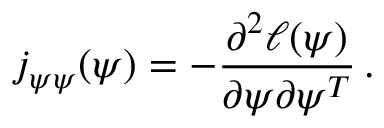Convert formula to latex. <formula><loc_0><loc_0><loc_500><loc_500>j _ { \psi \psi } ( \psi ) = - \frac { \partial ^ { 2 } \ell ( \psi ) } { \partial \psi \partial \psi ^ { T } } \, .</formula> 